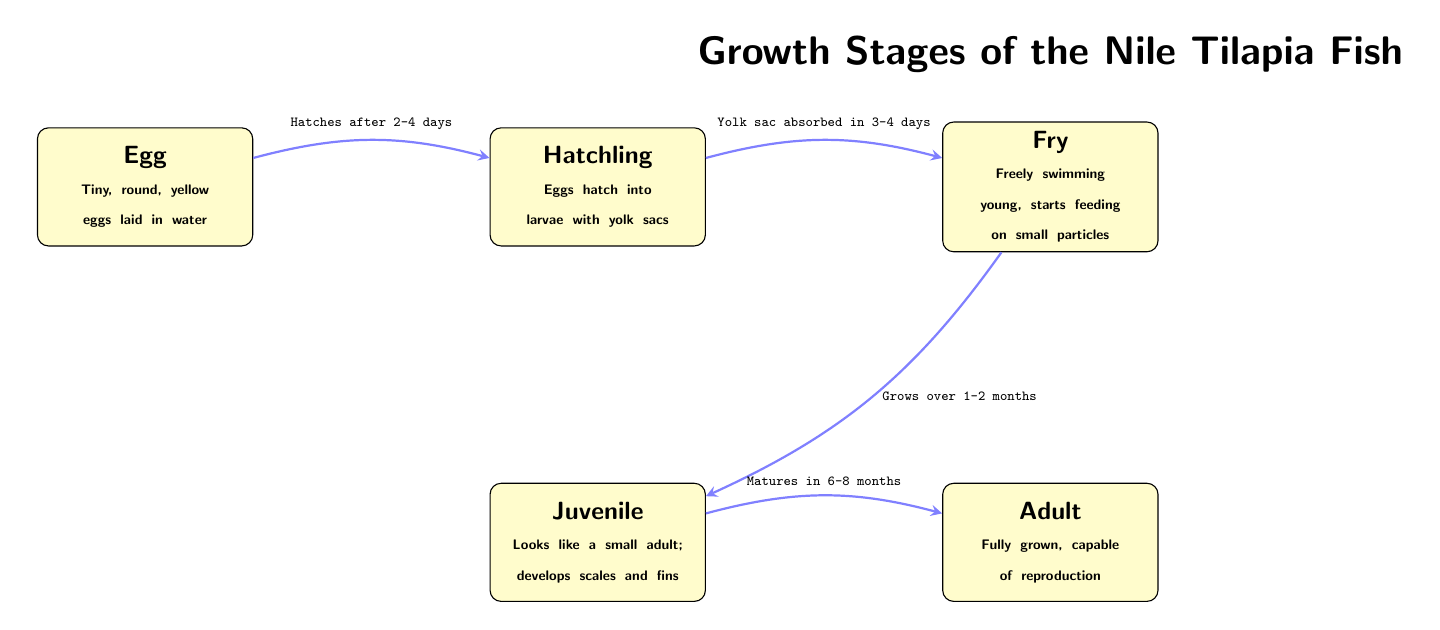What are Nile tilapia eggs like? The first node in the diagram describes the eggs as "Tiny, round, yellow eggs laid in water." This directly answers the question about the characteristics of the Nile tilapia eggs.
Answer: Tiny, round, yellow eggs laid in water How long does it take for Nile tilapia eggs to hatch? The arrow from the egg node to the hatchling node indicates that the eggs "Hatch after 2-4 days." This shows the time required for hatching.
Answer: 2-4 days What is the main difference between a fry and a hatchling? A hatchling is described as "Eggs hatch into larvae with yolk sacs," while a fry is described as "Freely swimming young, starts feeding on small particles." The comparison shows that the hatchling has not yet started to swim or feed.
Answer: Swimming and feeding What stage comes after the fry stage? By looking at the diagram, the arrow leads from the fry node to the juvenile node, indicating that the juvenile stage follows the fry stage.
Answer: Juvenile How long does it take for a fry to grow into a juvenile? According to the edge from the fry node to the juvenile node, it says "Grows over 1-2 months." This provides the time needed for the transition from fry to juvenile.
Answer: 1-2 months What stage of Nile tilapia fish matures in 6-8 months? The juvenile node connects to the adult node and indicates "Matures in 6-8 months." Thus, the adult is the stage that matures within that time frame.
Answer: Adult How many stages are there in the growth of Nile tilapia fish? Counting the nodes in the diagram, there are a total of five stages: egg, hatchling, fry, juvenile, and adult.
Answer: Five What is the significance of the yolk sac in the hatchling stage? The diagram notes that the yolk sac is absorbed in 3-4 days, which is a crucial development in the hatchling stage before it moves to fry. This signifies the transition of nourishment from the yolk sac to feeding.
Answer: Absorbed in 3-4 days At what stage does the fish start to develop scales and fins? The juvenile node states, "Looks like a small adult; develops scales and fins," indicating that this development occurs during the juvenile stage.
Answer: Juvenile 